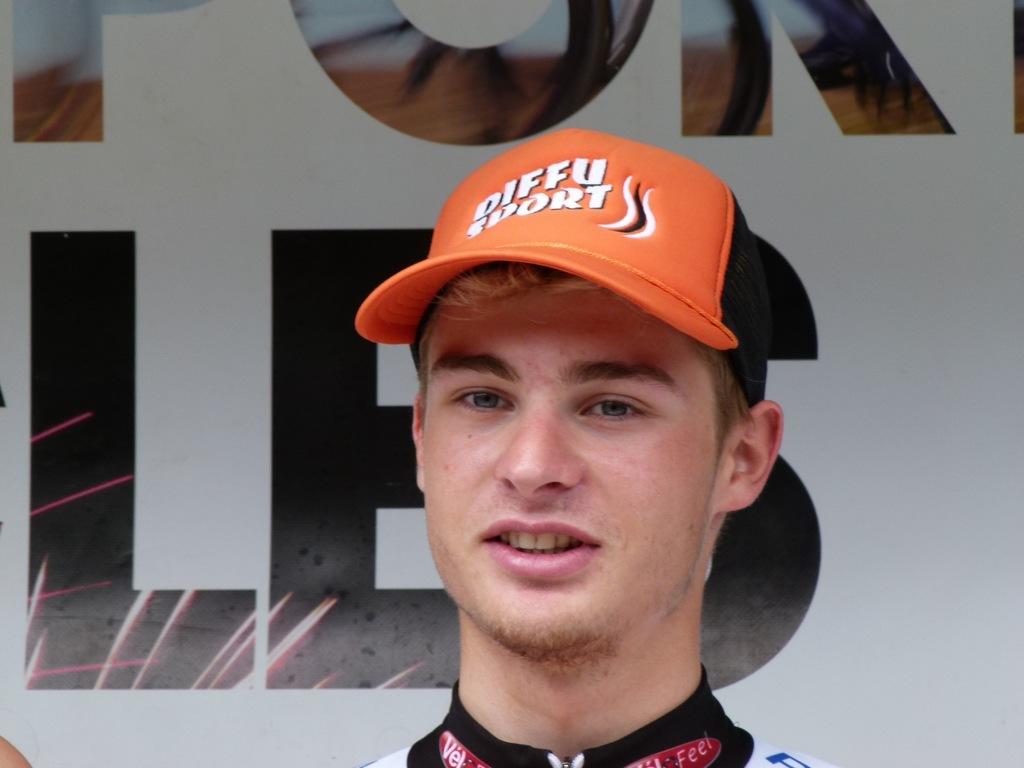What sport team does the person's hat reference?
Your response must be concise. Diffu sport. What is the white word on the right side of this man's collar?
Provide a succinct answer. Feel. 